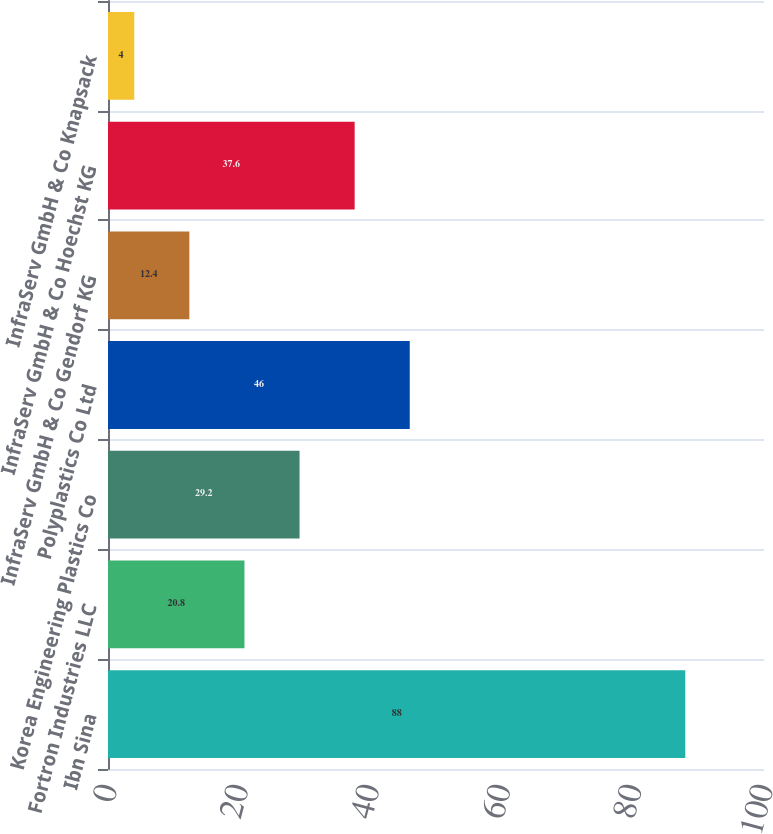<chart> <loc_0><loc_0><loc_500><loc_500><bar_chart><fcel>Ibn Sina<fcel>Fortron Industries LLC<fcel>Korea Engineering Plastics Co<fcel>Polyplastics Co Ltd<fcel>InfraServ GmbH & Co Gendorf KG<fcel>InfraServ GmbH & Co Hoechst KG<fcel>InfraServ GmbH & Co Knapsack<nl><fcel>88<fcel>20.8<fcel>29.2<fcel>46<fcel>12.4<fcel>37.6<fcel>4<nl></chart> 